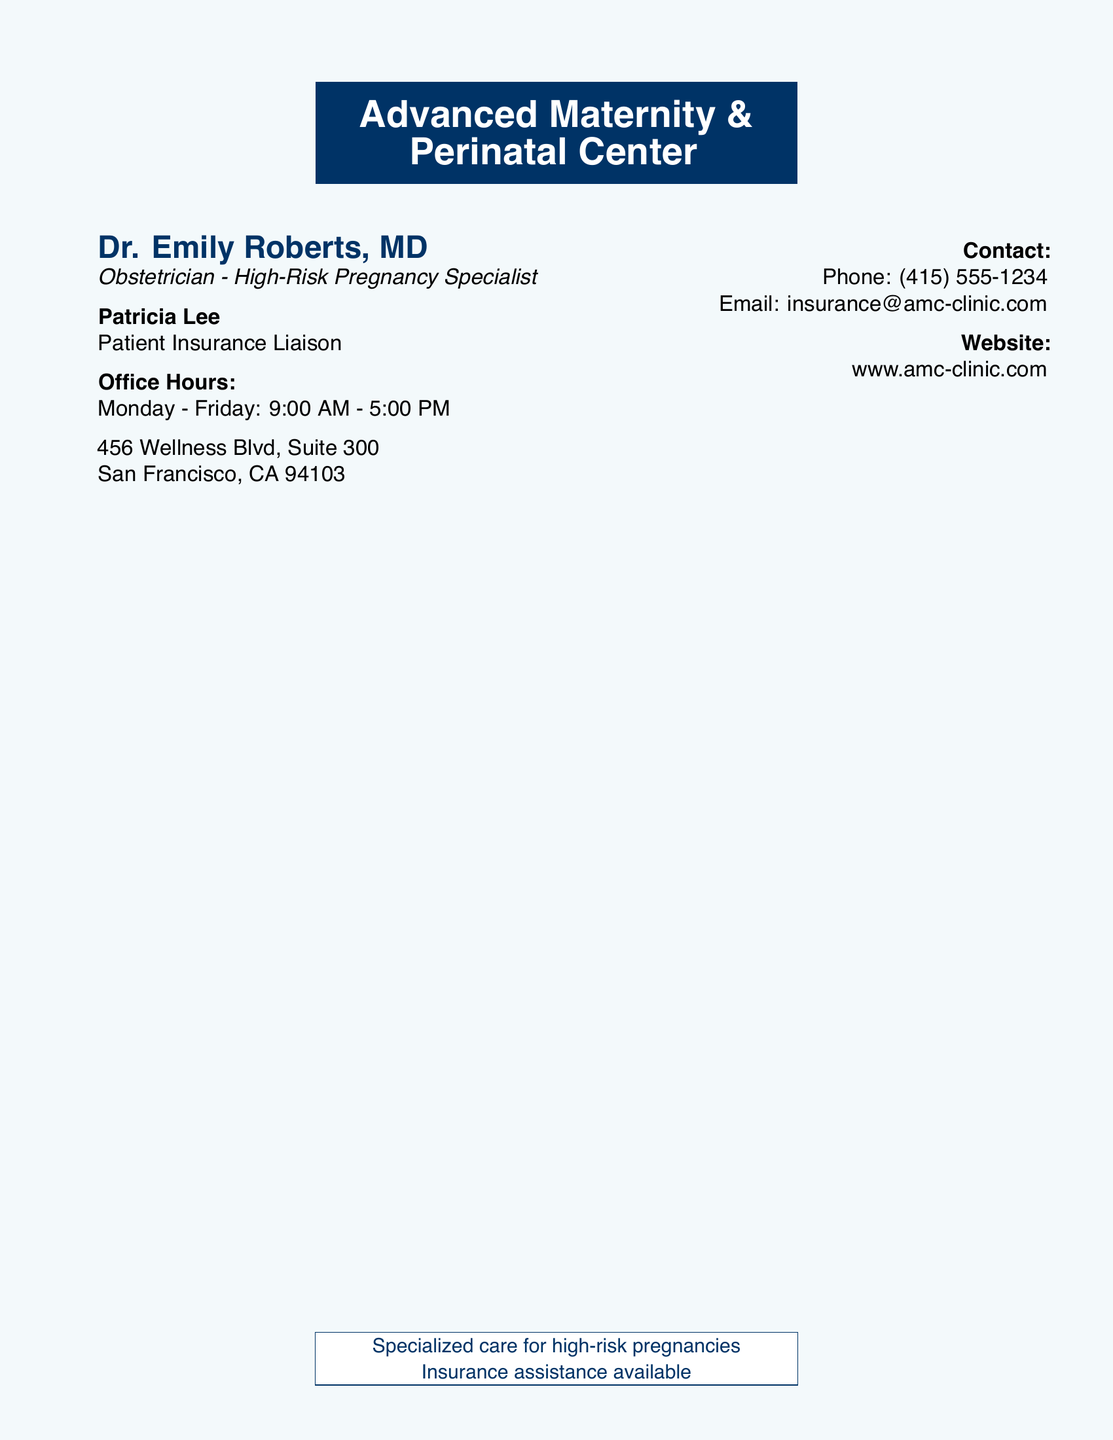What is the name of the doctor? The doctor's name is prominently displayed at the top of the document.
Answer: Dr. Emily Roberts, MD What is the title of the patient insurance liaison? Patricia Lee's title is stated next to her name in the document.
Answer: Patient Insurance Liaison What are the office hours? The office hours are detailed under the office hours section of the document.
Answer: Monday - Friday: 9:00 AM - 5:00 PM What is the street address? The street address can be found near the bottom of the document.
Answer: 456 Wellness Blvd, Suite 300 What city is the center located in? The city is part of the address provided in the document.
Answer: San Francisco What is the phone number for contact? The phone number is mentioned under the contact section of the document.
Answer: (415) 555-1234 What type of specialized care is provided? The type of care is indicated in the specialized care statement at the bottom of the document.
Answer: high-risk pregnancies What is the email address listed? The email address is found in the contact information section.
Answer: insurance@amc-clinic.com What is the website for the center? The website is clearly indicated in the document under the website section.
Answer: www.amc-clinic.com 